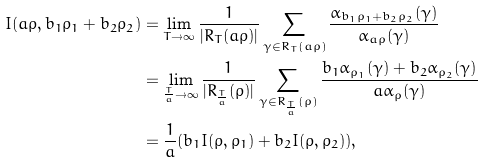<formula> <loc_0><loc_0><loc_500><loc_500>I ( a \rho , b _ { 1 } \rho _ { 1 } + b _ { 2 } \rho _ { 2 } ) & = \lim _ { T \to \infty } \frac { 1 } { | R _ { T } ( a \rho ) | } \sum _ { \gamma \in R _ { T } ( a \rho ) } \frac { \alpha _ { b _ { 1 } \rho _ { 1 } + b _ { 2 } \rho _ { 2 } } ( \gamma ) } { \alpha _ { a \rho } ( \gamma ) } \\ & = \lim _ { { \frac { T } { a } } \to \infty } \frac { 1 } { | R _ { \frac { T } { a } } ( \rho ) | } \sum _ { \gamma \in R _ { \frac { T } { a } } ( \rho ) } \frac { b _ { 1 } \alpha _ { \rho _ { 1 } } ( \gamma ) + b _ { 2 } \alpha _ { \rho _ { 2 } } ( \gamma ) } { a \alpha _ { \rho } ( \gamma ) } \\ & = \frac { 1 } { a } ( b _ { 1 } I ( \rho , \rho _ { 1 } ) + b _ { 2 } I ( \rho , \rho _ { 2 } ) ) ,</formula> 